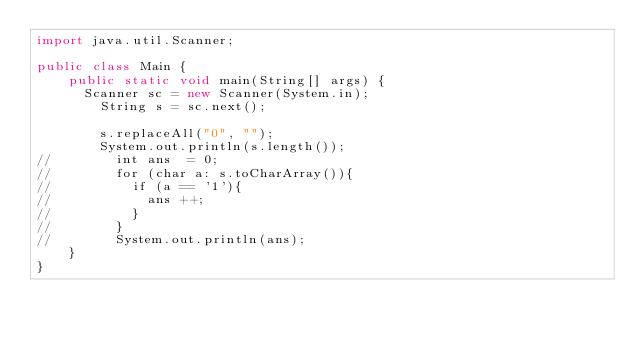<code> <loc_0><loc_0><loc_500><loc_500><_Java_>import java.util.Scanner;

public class Main {
    public static void main(String[] args) {
    	Scanner sc = new Scanner(System.in);
        String s = sc.next();
        
        s.replaceAll("0", "");
        System.out.println(s.length());
//        int ans  = 0;
//        for (char a: s.toCharArray()){
//        	if (a == '1'){
//        		ans ++;
//        	}
//        }
//        System.out.println(ans);
    }
}</code> 